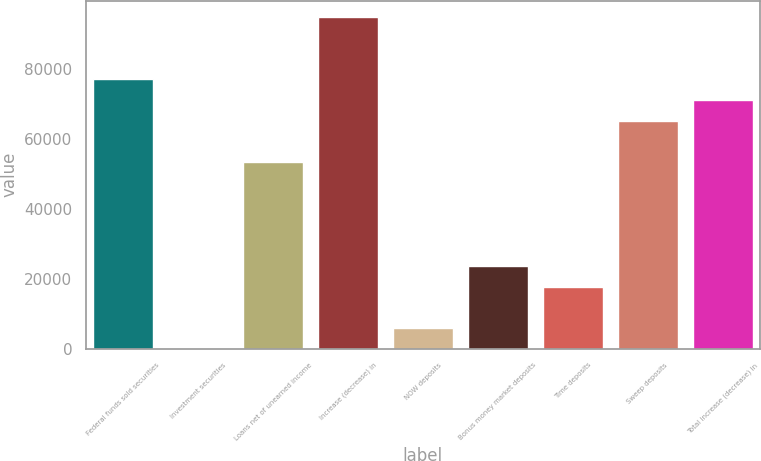Convert chart. <chart><loc_0><loc_0><loc_500><loc_500><bar_chart><fcel>Federal funds sold securities<fcel>Investment securities<fcel>Loans net of unearned income<fcel>Increase (decrease) in<fcel>NOW deposits<fcel>Bonus money market deposits<fcel>Time deposits<fcel>Sweep deposits<fcel>Total increase (decrease) in<nl><fcel>76998<fcel>12<fcel>53310<fcel>94764<fcel>5934<fcel>23700<fcel>17778<fcel>65154<fcel>71076<nl></chart> 